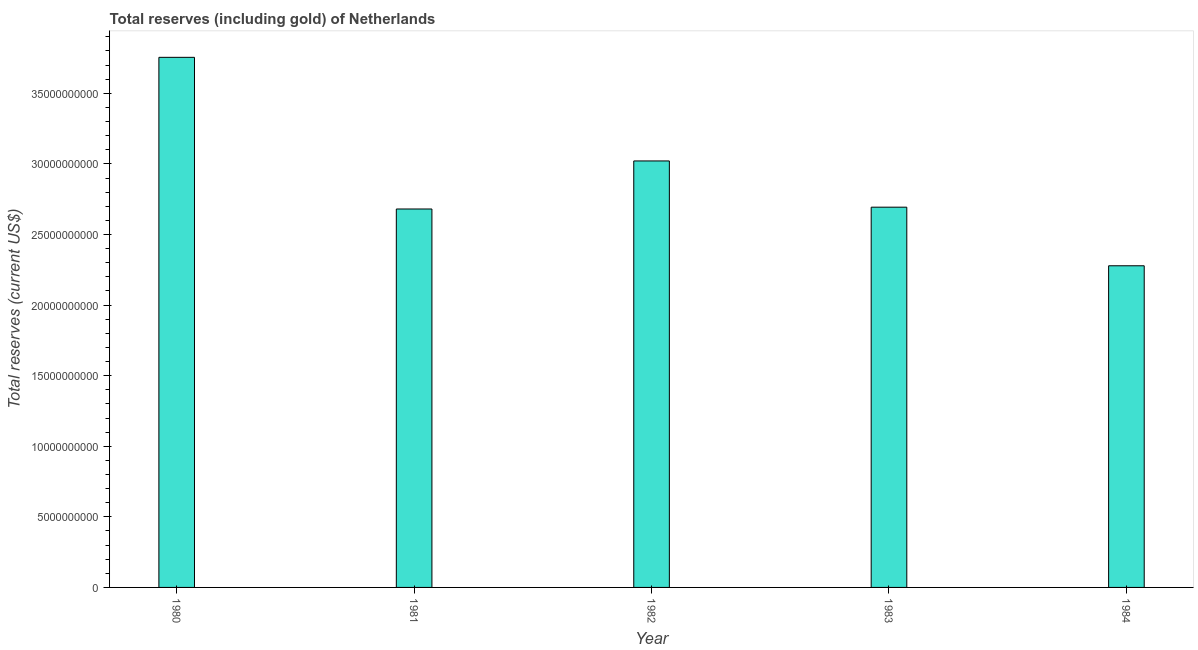What is the title of the graph?
Give a very brief answer. Total reserves (including gold) of Netherlands. What is the label or title of the Y-axis?
Your response must be concise. Total reserves (current US$). What is the total reserves (including gold) in 1982?
Make the answer very short. 3.02e+1. Across all years, what is the maximum total reserves (including gold)?
Offer a terse response. 3.75e+1. Across all years, what is the minimum total reserves (including gold)?
Offer a terse response. 2.28e+1. In which year was the total reserves (including gold) maximum?
Offer a very short reply. 1980. What is the sum of the total reserves (including gold)?
Keep it short and to the point. 1.44e+11. What is the difference between the total reserves (including gold) in 1981 and 1982?
Your response must be concise. -3.40e+09. What is the average total reserves (including gold) per year?
Your answer should be very brief. 2.89e+1. What is the median total reserves (including gold)?
Make the answer very short. 2.69e+1. In how many years, is the total reserves (including gold) greater than 27000000000 US$?
Your answer should be compact. 2. Do a majority of the years between 1984 and 1981 (inclusive) have total reserves (including gold) greater than 11000000000 US$?
Offer a very short reply. Yes. What is the ratio of the total reserves (including gold) in 1980 to that in 1984?
Give a very brief answer. 1.65. Is the difference between the total reserves (including gold) in 1980 and 1983 greater than the difference between any two years?
Keep it short and to the point. No. What is the difference between the highest and the second highest total reserves (including gold)?
Make the answer very short. 7.34e+09. Is the sum of the total reserves (including gold) in 1982 and 1983 greater than the maximum total reserves (including gold) across all years?
Your answer should be compact. Yes. What is the difference between the highest and the lowest total reserves (including gold)?
Keep it short and to the point. 1.48e+1. In how many years, is the total reserves (including gold) greater than the average total reserves (including gold) taken over all years?
Make the answer very short. 2. How many bars are there?
Give a very brief answer. 5. Are the values on the major ticks of Y-axis written in scientific E-notation?
Keep it short and to the point. No. What is the Total reserves (current US$) in 1980?
Give a very brief answer. 3.75e+1. What is the Total reserves (current US$) in 1981?
Ensure brevity in your answer.  2.68e+1. What is the Total reserves (current US$) in 1982?
Your answer should be compact. 3.02e+1. What is the Total reserves (current US$) in 1983?
Keep it short and to the point. 2.69e+1. What is the Total reserves (current US$) in 1984?
Your answer should be compact. 2.28e+1. What is the difference between the Total reserves (current US$) in 1980 and 1981?
Provide a short and direct response. 1.07e+1. What is the difference between the Total reserves (current US$) in 1980 and 1982?
Your answer should be very brief. 7.34e+09. What is the difference between the Total reserves (current US$) in 1980 and 1983?
Your response must be concise. 1.06e+1. What is the difference between the Total reserves (current US$) in 1980 and 1984?
Ensure brevity in your answer.  1.48e+1. What is the difference between the Total reserves (current US$) in 1981 and 1982?
Offer a terse response. -3.40e+09. What is the difference between the Total reserves (current US$) in 1981 and 1983?
Your response must be concise. -1.29e+08. What is the difference between the Total reserves (current US$) in 1981 and 1984?
Your response must be concise. 4.02e+09. What is the difference between the Total reserves (current US$) in 1982 and 1983?
Make the answer very short. 3.28e+09. What is the difference between the Total reserves (current US$) in 1982 and 1984?
Your answer should be compact. 7.43e+09. What is the difference between the Total reserves (current US$) in 1983 and 1984?
Provide a short and direct response. 4.15e+09. What is the ratio of the Total reserves (current US$) in 1980 to that in 1981?
Keep it short and to the point. 1.4. What is the ratio of the Total reserves (current US$) in 1980 to that in 1982?
Provide a succinct answer. 1.24. What is the ratio of the Total reserves (current US$) in 1980 to that in 1983?
Ensure brevity in your answer.  1.39. What is the ratio of the Total reserves (current US$) in 1980 to that in 1984?
Your response must be concise. 1.65. What is the ratio of the Total reserves (current US$) in 1981 to that in 1982?
Offer a terse response. 0.89. What is the ratio of the Total reserves (current US$) in 1981 to that in 1984?
Your answer should be compact. 1.18. What is the ratio of the Total reserves (current US$) in 1982 to that in 1983?
Your answer should be compact. 1.12. What is the ratio of the Total reserves (current US$) in 1982 to that in 1984?
Your response must be concise. 1.33. What is the ratio of the Total reserves (current US$) in 1983 to that in 1984?
Ensure brevity in your answer.  1.18. 